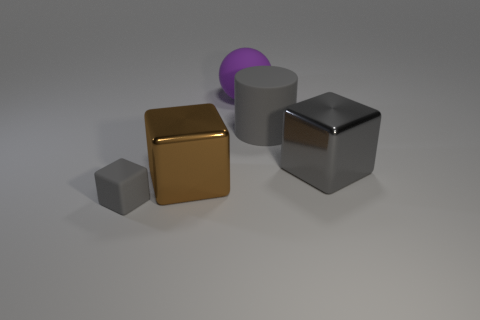What is the color of the metallic object behind the metallic cube that is to the left of the matte sphere?
Offer a very short reply. Gray. Are there an equal number of large brown objects that are in front of the big brown shiny thing and big brown blocks?
Your answer should be very brief. No. What number of gray metallic objects are to the right of the big shiny object that is on the right side of the big rubber object in front of the sphere?
Your answer should be compact. 0. The big shiny cube right of the big matte cylinder is what color?
Give a very brief answer. Gray. The thing that is in front of the big rubber cylinder and to the right of the large ball is made of what material?
Make the answer very short. Metal. What number of big purple rubber objects are to the right of the metal block that is right of the purple object?
Your response must be concise. 0. The big brown metal object has what shape?
Provide a short and direct response. Cube. What is the shape of the big thing that is the same material as the big ball?
Give a very brief answer. Cylinder. There is a large metallic object on the left side of the big purple rubber ball; is its shape the same as the big purple thing?
Make the answer very short. No. What is the shape of the metal thing that is left of the big rubber cylinder?
Your response must be concise. Cube. 